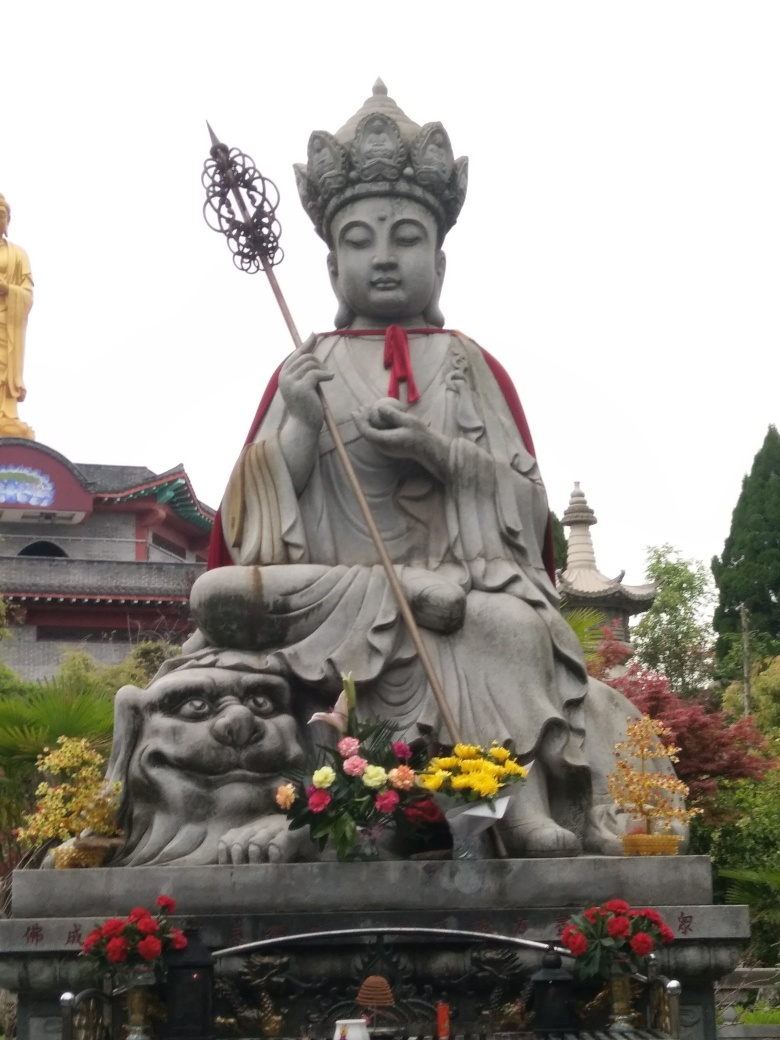Can you describe what the statue represents and what cultural significance it might have? The statue in the image represents a figure commonly seen in East Asian cultures, often associated with Buddhism. It appears to depict a bodhisattva, a being that embodies compassion and is dedicated to achieving enlightenment for the sake of all beings. The specific iconography, with the figure holding a staff and what may be a wish-fulfilling jewel, along with the presence of a lion-like creature at the base, may provide clues to the exact identity and symbology within a particular cultural context. Such statues are significant as they serve as objects of reverence and meditation, inspiring devotees to embody the virtues represented by the bodhisattva. 